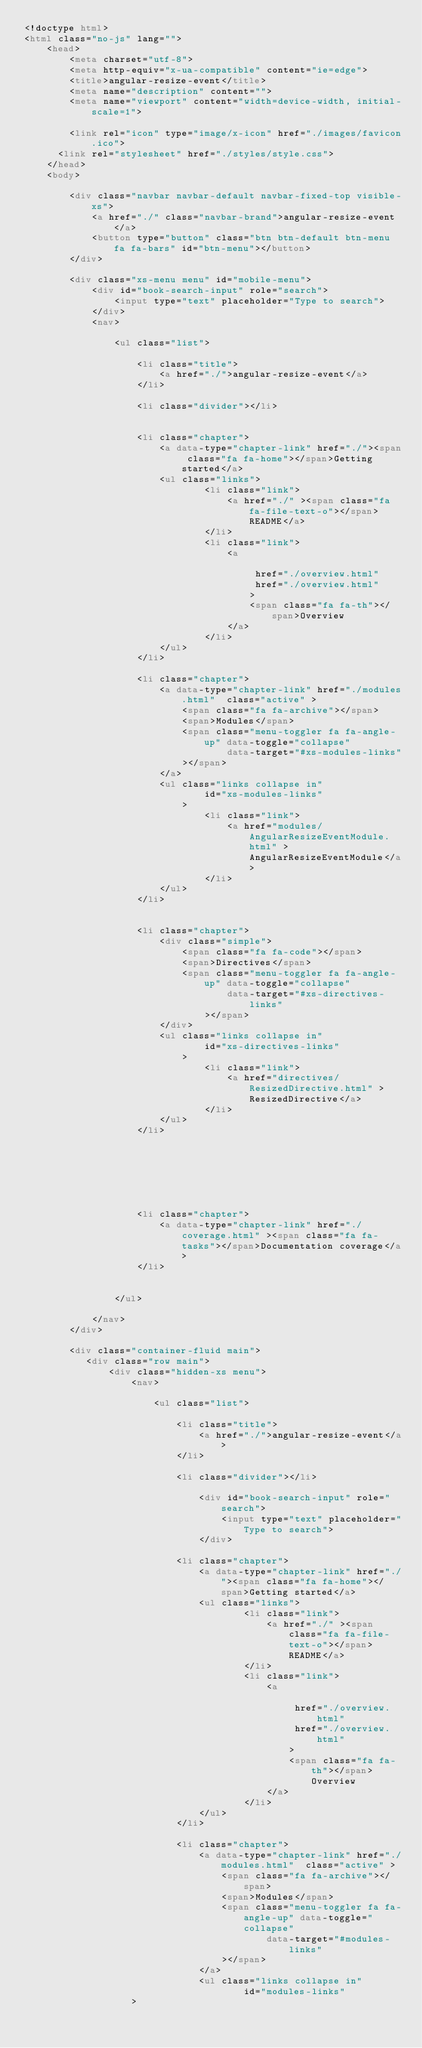Convert code to text. <code><loc_0><loc_0><loc_500><loc_500><_HTML_><!doctype html>
<html class="no-js" lang="">
    <head>
        <meta charset="utf-8">
        <meta http-equiv="x-ua-compatible" content="ie=edge">
        <title>angular-resize-event</title>
        <meta name="description" content="">
        <meta name="viewport" content="width=device-width, initial-scale=1">

        <link rel="icon" type="image/x-icon" href="./images/favicon.ico">
	    <link rel="stylesheet" href="./styles/style.css">
    </head>
    <body>

        <div class="navbar navbar-default navbar-fixed-top visible-xs">
            <a href="./" class="navbar-brand">angular-resize-event</a>
            <button type="button" class="btn btn-default btn-menu fa fa-bars" id="btn-menu"></button>
        </div>

        <div class="xs-menu menu" id="mobile-menu">
            <div id="book-search-input" role="search">
                <input type="text" placeholder="Type to search">
            </div>
            <nav>
            
                <ul class="list">
            
                    <li class="title">
                        <a href="./">angular-resize-event</a>
                    </li>
            
                    <li class="divider"></li>
            
            
                    <li class="chapter">
                        <a data-type="chapter-link" href="./"><span class="fa fa-home"></span>Getting started</a>
                        <ul class="links">
                                <li class="link">
                                    <a href="./" ><span class="fa fa-file-text-o"></span>README</a>
                                </li>
                                <li class="link">
                                    <a 
                                        
                                         href="./overview.html" 
                                         href="./overview.html" 
                                        >
                                        <span class="fa fa-th"></span>Overview
                                    </a>
                                </li>
                        </ul>
                    </li>
            
                    <li class="chapter">
                        <a data-type="chapter-link" href="./modules.html"  class="active" >
                            <span class="fa fa-archive"></span>
                            <span>Modules</span>
                            <span class="menu-toggler fa fa-angle-up" data-toggle="collapse"
                                    data-target="#xs-modules-links"
                            ></span>
                        </a>
                        <ul class="links collapse in"
                                id="xs-modules-links"
                            >
                                <li class="link">
                                    <a href="modules/AngularResizeEventModule.html" >AngularResizeEventModule</a>
                                </li>
                        </ul>
                    </li>
            
            
                    <li class="chapter">
                        <div class="simple">
                            <span class="fa fa-code"></span>
                            <span>Directives</span>
                            <span class="menu-toggler fa fa-angle-up" data-toggle="collapse"
                                    data-target="#xs-directives-links"
                                ></span>
                        </div>
                        <ul class="links collapse in"
                                id="xs-directives-links"
                            >
                                <li class="link">
                                    <a href="directives/ResizedDirective.html" >ResizedDirective</a>
                                </li>
                        </ul>
                    </li>
            
            
            
            
            
            
            
                    <li class="chapter">
                        <a data-type="chapter-link" href="./coverage.html" ><span class="fa fa-tasks"></span>Documentation coverage</a>
                    </li>
            
            
                </ul>
            
            </nav>
        </div>

        <div class="container-fluid main">
           <div class="row main">
               <div class="hidden-xs menu">
                   <nav>
                   
                       <ul class="list">
                   
                           <li class="title">
                               <a href="./">angular-resize-event</a>
                           </li>
                   
                           <li class="divider"></li>
                   
                               <div id="book-search-input" role="search">
                                   <input type="text" placeholder="Type to search">
                               </div>
                   
                           <li class="chapter">
                               <a data-type="chapter-link" href="./"><span class="fa fa-home"></span>Getting started</a>
                               <ul class="links">
                                       <li class="link">
                                           <a href="./" ><span class="fa fa-file-text-o"></span>README</a>
                                       </li>
                                       <li class="link">
                                           <a 
                                               
                                                href="./overview.html" 
                                                href="./overview.html" 
                                               >
                                               <span class="fa fa-th"></span>Overview
                                           </a>
                                       </li>
                               </ul>
                           </li>
                   
                           <li class="chapter">
                               <a data-type="chapter-link" href="./modules.html"  class="active" >
                                   <span class="fa fa-archive"></span>
                                   <span>Modules</span>
                                   <span class="menu-toggler fa fa-angle-up" data-toggle="collapse"
                                           data-target="#modules-links"
                                   ></span>
                               </a>
                               <ul class="links collapse in"
                                       id="modules-links"
                   ></code> 